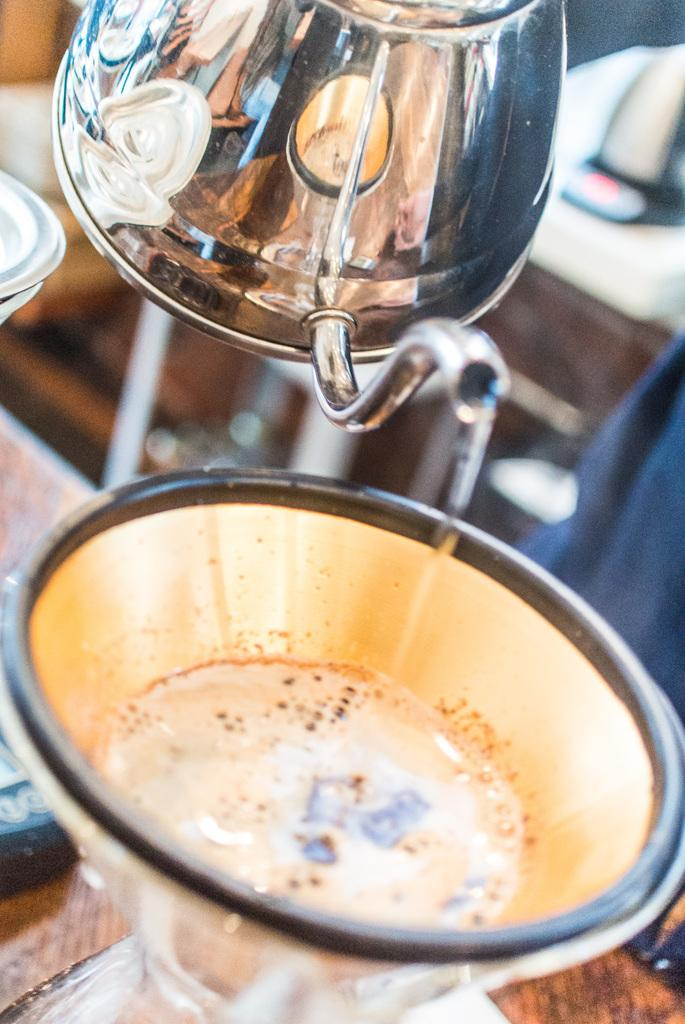What is on the table in the image? There is a glass on the table in the image. What other object can be seen in the image? There is a kettle in the image. Can you describe the person in the image? There is a person in the image, but no specific details about their appearance or actions are provided. What type of furniture is present in the image? There is a cabinet in the image. Where might this image have been taken? The image may have been taken in a hotel, but this is not definitively known from the facts provided. How does the wind affect the person in the image? There is no wind present in the image, so it cannot affect the person. What color is the brain of the person in the image? There is no brain visible in the image, so we cannot determine its color. 